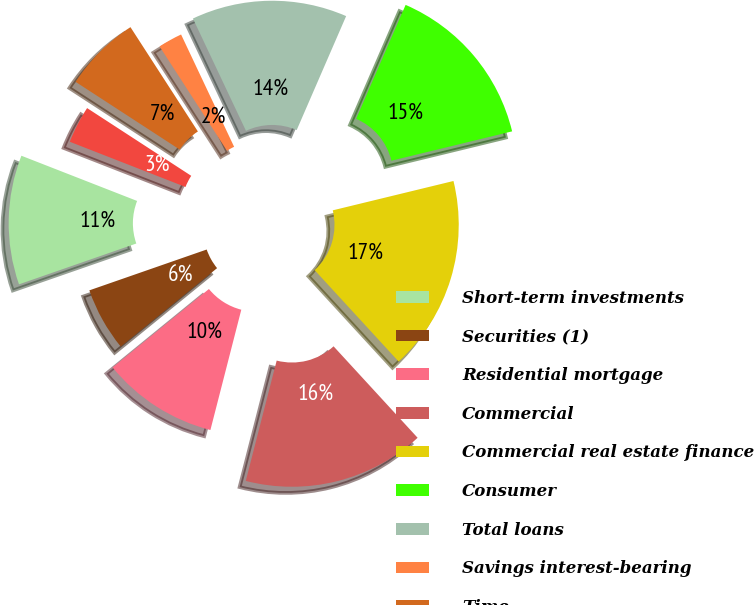<chart> <loc_0><loc_0><loc_500><loc_500><pie_chart><fcel>Short-term investments<fcel>Securities (1)<fcel>Residential mortgage<fcel>Commercial<fcel>Commercial real estate finance<fcel>Consumer<fcel>Total loans<fcel>Savings interest-bearing<fcel>Time<fcel>Total deposits<nl><fcel>11.26%<fcel>5.55%<fcel>10.12%<fcel>15.83%<fcel>16.97%<fcel>14.69%<fcel>13.54%<fcel>2.11%<fcel>6.69%<fcel>3.25%<nl></chart> 